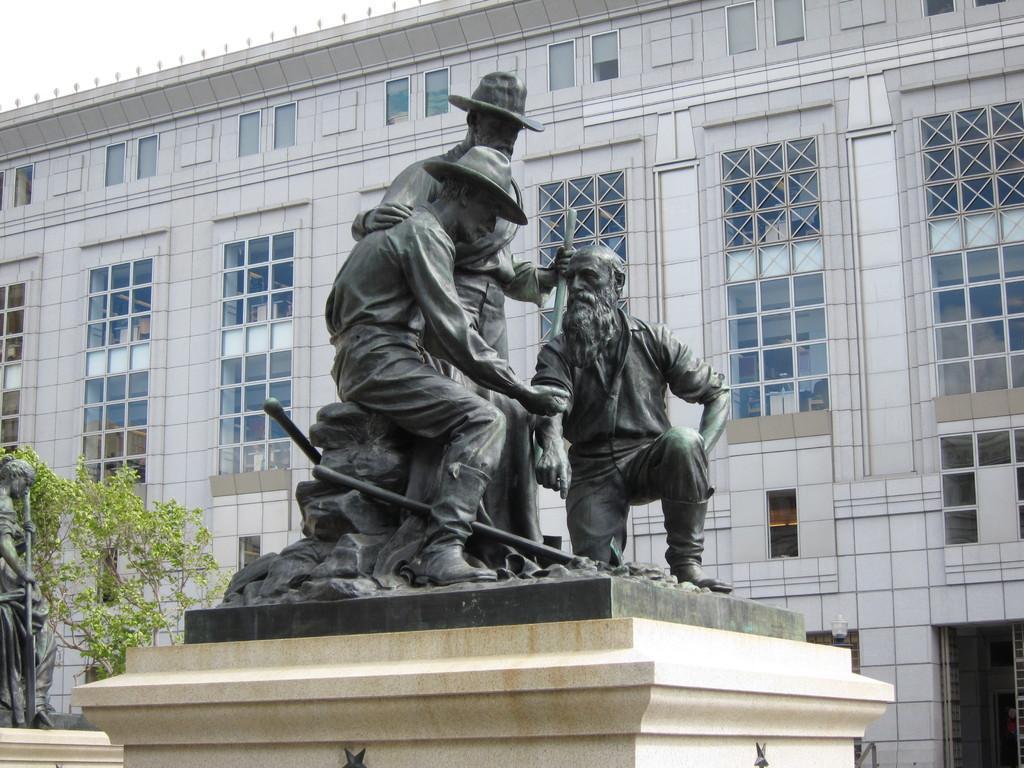How would you summarize this image in a sentence or two? In this picture we can see building, there are some glass windows to the wall, in front we can see some scepters. 